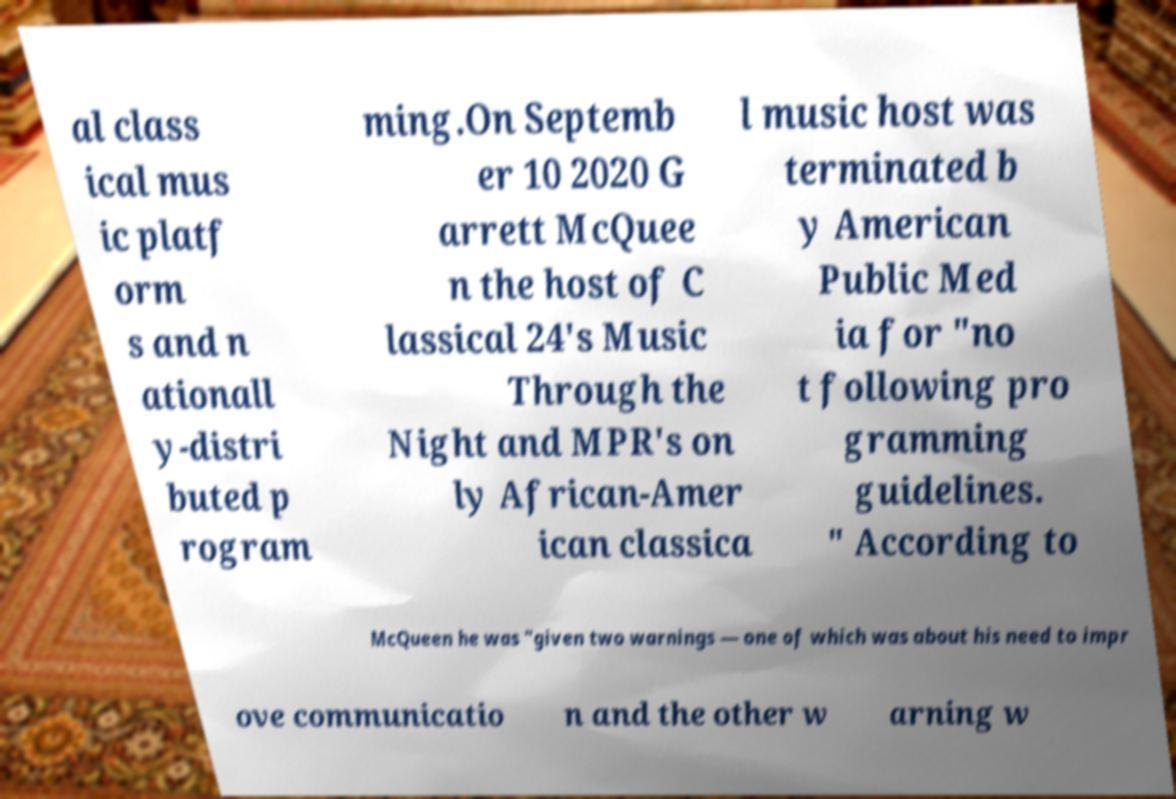What messages or text are displayed in this image? I need them in a readable, typed format. al class ical mus ic platf orm s and n ationall y-distri buted p rogram ming.On Septemb er 10 2020 G arrett McQuee n the host of C lassical 24's Music Through the Night and MPR's on ly African-Amer ican classica l music host was terminated b y American Public Med ia for "no t following pro gramming guidelines. " According to McQueen he was "given two warnings — one of which was about his need to impr ove communicatio n and the other w arning w 